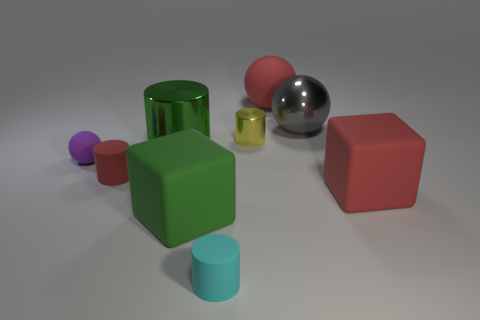What size is the other green object that is the same shape as the small shiny thing?
Offer a terse response. Large. What is the shape of the small metal thing?
Offer a terse response. Cylinder. Does the tiny cyan object have the same material as the big cube that is right of the red matte sphere?
Your answer should be compact. Yes. How many matte things are red cylinders or green cylinders?
Keep it short and to the point. 1. There is a green object that is in front of the small purple object; what is its size?
Ensure brevity in your answer.  Large. There is a gray sphere that is the same material as the large green cylinder; what is its size?
Your response must be concise. Large. What number of rubber spheres have the same color as the tiny shiny thing?
Provide a short and direct response. 0. Is there a red matte ball?
Your response must be concise. Yes. There is a gray object; is it the same shape as the red object that is left of the small yellow thing?
Give a very brief answer. No. What is the color of the large rubber thing that is behind the big green object that is left of the large block that is to the left of the gray ball?
Provide a short and direct response. Red. 